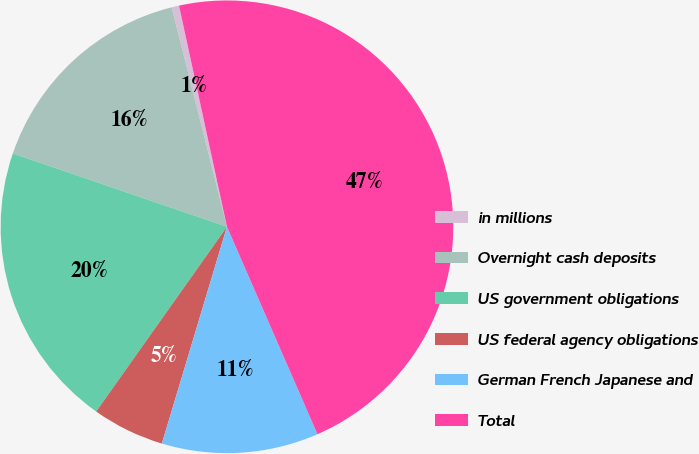<chart> <loc_0><loc_0><loc_500><loc_500><pie_chart><fcel>in millions<fcel>Overnight cash deposits<fcel>US government obligations<fcel>US federal agency obligations<fcel>German French Japanese and<fcel>Total<nl><fcel>0.53%<fcel>15.82%<fcel>20.45%<fcel>5.16%<fcel>11.19%<fcel>46.85%<nl></chart> 